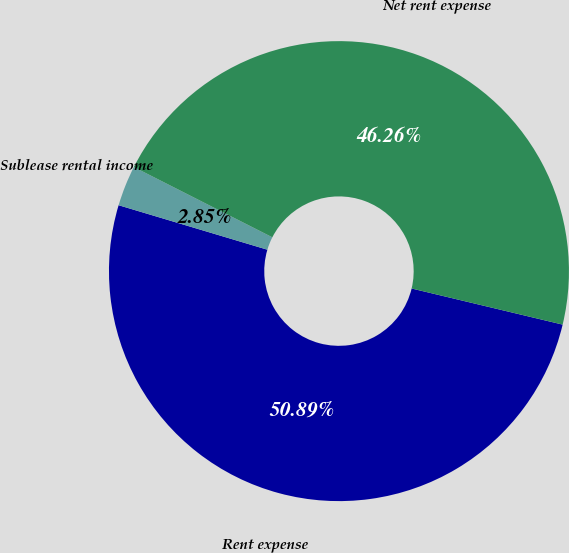<chart> <loc_0><loc_0><loc_500><loc_500><pie_chart><fcel>Rent expense<fcel>Sublease rental income<fcel>Net rent expense<nl><fcel>50.89%<fcel>2.85%<fcel>46.26%<nl></chart> 